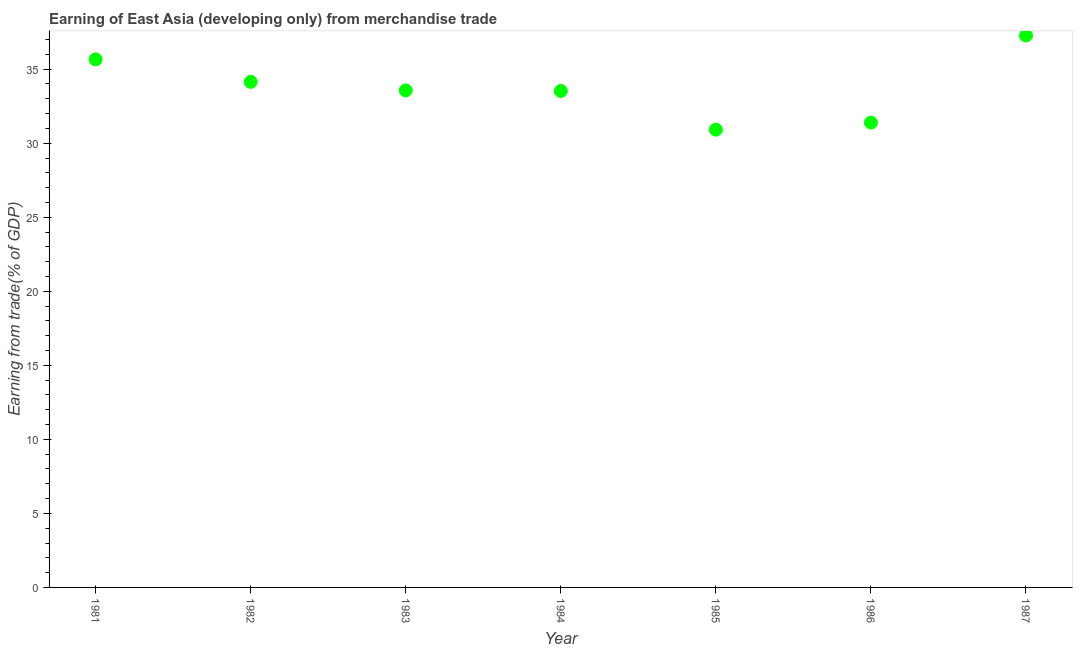What is the earning from merchandise trade in 1986?
Your answer should be compact. 31.39. Across all years, what is the maximum earning from merchandise trade?
Provide a succinct answer. 37.27. Across all years, what is the minimum earning from merchandise trade?
Offer a terse response. 30.92. In which year was the earning from merchandise trade maximum?
Keep it short and to the point. 1987. In which year was the earning from merchandise trade minimum?
Provide a short and direct response. 1985. What is the sum of the earning from merchandise trade?
Your response must be concise. 236.48. What is the difference between the earning from merchandise trade in 1983 and 1986?
Ensure brevity in your answer.  2.17. What is the average earning from merchandise trade per year?
Offer a terse response. 33.78. What is the median earning from merchandise trade?
Offer a terse response. 33.56. In how many years, is the earning from merchandise trade greater than 20 %?
Your response must be concise. 7. What is the ratio of the earning from merchandise trade in 1981 to that in 1984?
Keep it short and to the point. 1.06. Is the difference between the earning from merchandise trade in 1984 and 1986 greater than the difference between any two years?
Give a very brief answer. No. What is the difference between the highest and the second highest earning from merchandise trade?
Provide a succinct answer. 1.61. Is the sum of the earning from merchandise trade in 1983 and 1987 greater than the maximum earning from merchandise trade across all years?
Give a very brief answer. Yes. What is the difference between the highest and the lowest earning from merchandise trade?
Provide a short and direct response. 6.36. In how many years, is the earning from merchandise trade greater than the average earning from merchandise trade taken over all years?
Provide a succinct answer. 3. How many dotlines are there?
Offer a terse response. 1. How many years are there in the graph?
Your answer should be compact. 7. What is the difference between two consecutive major ticks on the Y-axis?
Your answer should be very brief. 5. Are the values on the major ticks of Y-axis written in scientific E-notation?
Your response must be concise. No. Does the graph contain any zero values?
Offer a very short reply. No. What is the title of the graph?
Provide a succinct answer. Earning of East Asia (developing only) from merchandise trade. What is the label or title of the X-axis?
Your answer should be compact. Year. What is the label or title of the Y-axis?
Make the answer very short. Earning from trade(% of GDP). What is the Earning from trade(% of GDP) in 1981?
Offer a terse response. 35.66. What is the Earning from trade(% of GDP) in 1982?
Your response must be concise. 34.14. What is the Earning from trade(% of GDP) in 1983?
Your response must be concise. 33.56. What is the Earning from trade(% of GDP) in 1984?
Ensure brevity in your answer.  33.53. What is the Earning from trade(% of GDP) in 1985?
Keep it short and to the point. 30.92. What is the Earning from trade(% of GDP) in 1986?
Offer a terse response. 31.39. What is the Earning from trade(% of GDP) in 1987?
Your answer should be very brief. 37.27. What is the difference between the Earning from trade(% of GDP) in 1981 and 1982?
Offer a terse response. 1.52. What is the difference between the Earning from trade(% of GDP) in 1981 and 1983?
Offer a very short reply. 2.1. What is the difference between the Earning from trade(% of GDP) in 1981 and 1984?
Offer a very short reply. 2.13. What is the difference between the Earning from trade(% of GDP) in 1981 and 1985?
Make the answer very short. 4.75. What is the difference between the Earning from trade(% of GDP) in 1981 and 1986?
Ensure brevity in your answer.  4.27. What is the difference between the Earning from trade(% of GDP) in 1981 and 1987?
Your response must be concise. -1.61. What is the difference between the Earning from trade(% of GDP) in 1982 and 1983?
Your response must be concise. 0.58. What is the difference between the Earning from trade(% of GDP) in 1982 and 1984?
Your response must be concise. 0.61. What is the difference between the Earning from trade(% of GDP) in 1982 and 1985?
Provide a succinct answer. 3.23. What is the difference between the Earning from trade(% of GDP) in 1982 and 1986?
Keep it short and to the point. 2.75. What is the difference between the Earning from trade(% of GDP) in 1982 and 1987?
Make the answer very short. -3.13. What is the difference between the Earning from trade(% of GDP) in 1983 and 1984?
Ensure brevity in your answer.  0.03. What is the difference between the Earning from trade(% of GDP) in 1983 and 1985?
Your answer should be very brief. 2.65. What is the difference between the Earning from trade(% of GDP) in 1983 and 1986?
Keep it short and to the point. 2.17. What is the difference between the Earning from trade(% of GDP) in 1983 and 1987?
Provide a short and direct response. -3.71. What is the difference between the Earning from trade(% of GDP) in 1984 and 1985?
Offer a terse response. 2.61. What is the difference between the Earning from trade(% of GDP) in 1984 and 1986?
Give a very brief answer. 2.14. What is the difference between the Earning from trade(% of GDP) in 1984 and 1987?
Ensure brevity in your answer.  -3.74. What is the difference between the Earning from trade(% of GDP) in 1985 and 1986?
Provide a succinct answer. -0.48. What is the difference between the Earning from trade(% of GDP) in 1985 and 1987?
Ensure brevity in your answer.  -6.36. What is the difference between the Earning from trade(% of GDP) in 1986 and 1987?
Your answer should be very brief. -5.88. What is the ratio of the Earning from trade(% of GDP) in 1981 to that in 1982?
Provide a short and direct response. 1.04. What is the ratio of the Earning from trade(% of GDP) in 1981 to that in 1983?
Ensure brevity in your answer.  1.06. What is the ratio of the Earning from trade(% of GDP) in 1981 to that in 1984?
Give a very brief answer. 1.06. What is the ratio of the Earning from trade(% of GDP) in 1981 to that in 1985?
Your answer should be compact. 1.15. What is the ratio of the Earning from trade(% of GDP) in 1981 to that in 1986?
Provide a succinct answer. 1.14. What is the ratio of the Earning from trade(% of GDP) in 1982 to that in 1984?
Give a very brief answer. 1.02. What is the ratio of the Earning from trade(% of GDP) in 1982 to that in 1985?
Give a very brief answer. 1.1. What is the ratio of the Earning from trade(% of GDP) in 1982 to that in 1986?
Your response must be concise. 1.09. What is the ratio of the Earning from trade(% of GDP) in 1982 to that in 1987?
Make the answer very short. 0.92. What is the ratio of the Earning from trade(% of GDP) in 1983 to that in 1985?
Your answer should be compact. 1.09. What is the ratio of the Earning from trade(% of GDP) in 1983 to that in 1986?
Provide a short and direct response. 1.07. What is the ratio of the Earning from trade(% of GDP) in 1983 to that in 1987?
Offer a very short reply. 0.9. What is the ratio of the Earning from trade(% of GDP) in 1984 to that in 1985?
Your response must be concise. 1.08. What is the ratio of the Earning from trade(% of GDP) in 1984 to that in 1986?
Provide a short and direct response. 1.07. What is the ratio of the Earning from trade(% of GDP) in 1984 to that in 1987?
Provide a succinct answer. 0.9. What is the ratio of the Earning from trade(% of GDP) in 1985 to that in 1987?
Offer a terse response. 0.83. What is the ratio of the Earning from trade(% of GDP) in 1986 to that in 1987?
Your answer should be compact. 0.84. 